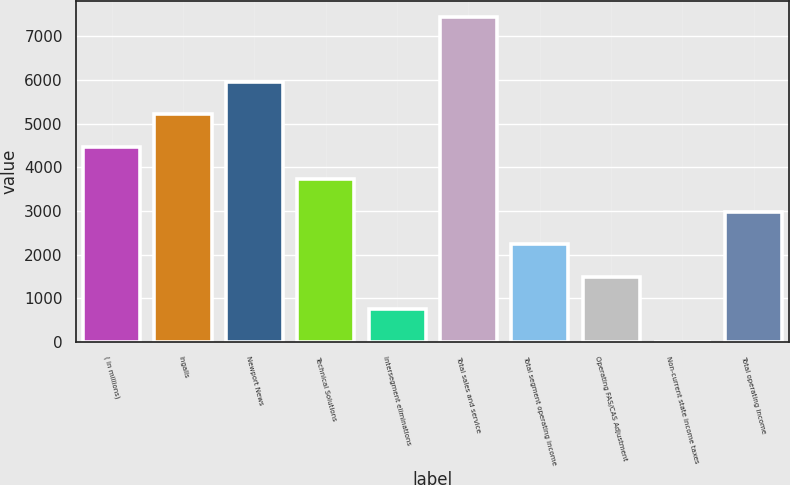Convert chart. <chart><loc_0><loc_0><loc_500><loc_500><bar_chart><fcel>( in millions)<fcel>Ingalls<fcel>Newport News<fcel>Technical Solutions<fcel>Intersegment eliminations<fcel>Total sales and service<fcel>Total segment operating income<fcel>Operating FAS/CAS Adjustment<fcel>Non-current state income taxes<fcel>Total operating income<nl><fcel>4469.4<fcel>5212.3<fcel>5955.2<fcel>3726.5<fcel>754.9<fcel>7441<fcel>2240.7<fcel>1497.8<fcel>12<fcel>2983.6<nl></chart> 